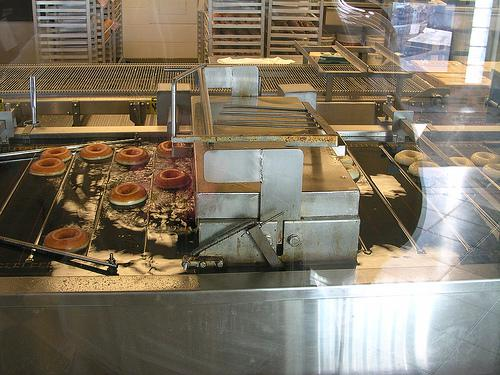Question: what is in the picture?
Choices:
A. Donuts.
B. Muffins.
C. Cupcakes.
D. Pies.
Answer with the letter. Answer: A Question: where are the donuts?
Choices:
A. Break room.
B. Kitchen.
C. Person's hand.
D. Bakery.
Answer with the letter. Answer: D Question: what kind of donuts are in the picture?
Choices:
A. Glazed.
B. Long johns.
C. Cake.
D. Jelly filled.
Answer with the letter. Answer: A Question: what is in the background?
Choices:
A. Books.
B. Shelves.
C. Racks.
D. Figurines.
Answer with the letter. Answer: C Question: what are on the racks?
Choices:
A. Candy bars.
B. Chips.
C. Gum.
D. Baked goods.
Answer with the letter. Answer: D Question: how many racks are in the back?
Choices:
A. Two.
B. Four.
C. Three.
D. Five.
Answer with the letter. Answer: C Question: what is the material of the equipment in the kitchen?
Choices:
A. Glass.
B. Plastic.
C. Steel.
D. Ceramic.
Answer with the letter. Answer: C 